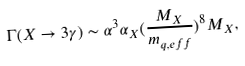<formula> <loc_0><loc_0><loc_500><loc_500>\Gamma ( X \rightarrow 3 \gamma ) \sim \alpha ^ { 3 } \alpha _ { X } ( \frac { M _ { X } } { m _ { q , e f f } } ) ^ { 8 } M _ { X } ,</formula> 